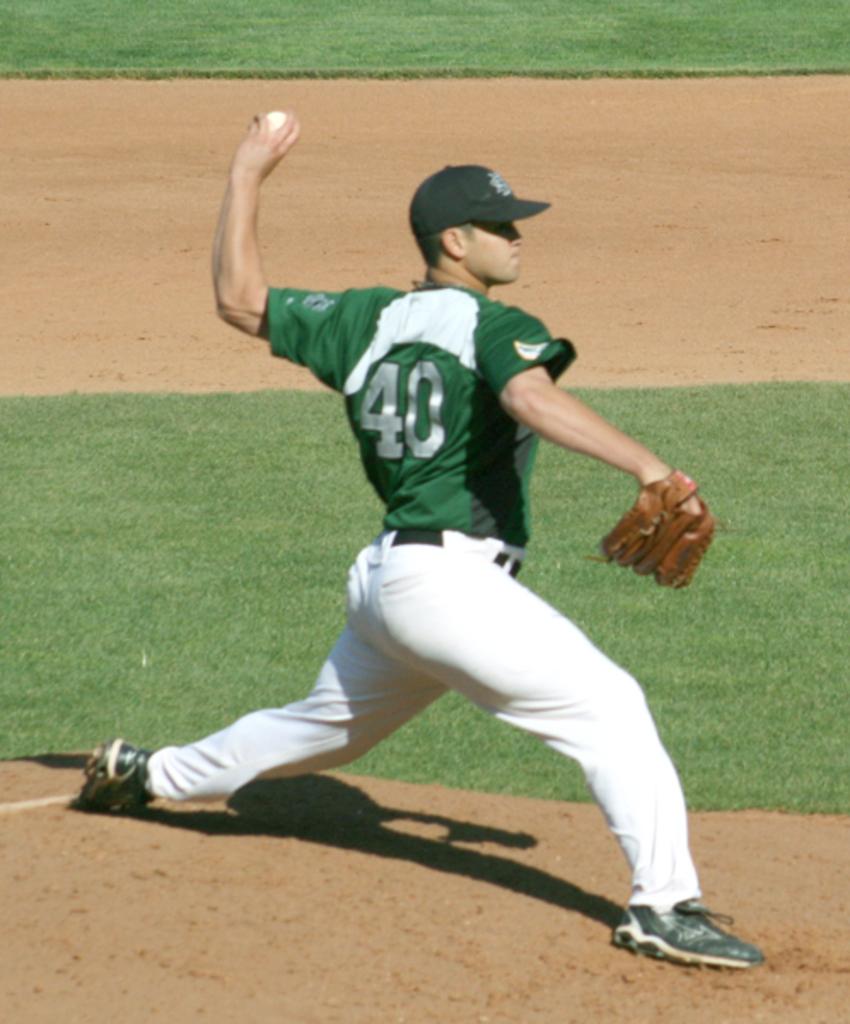What is this players number?
Offer a terse response. 40. 